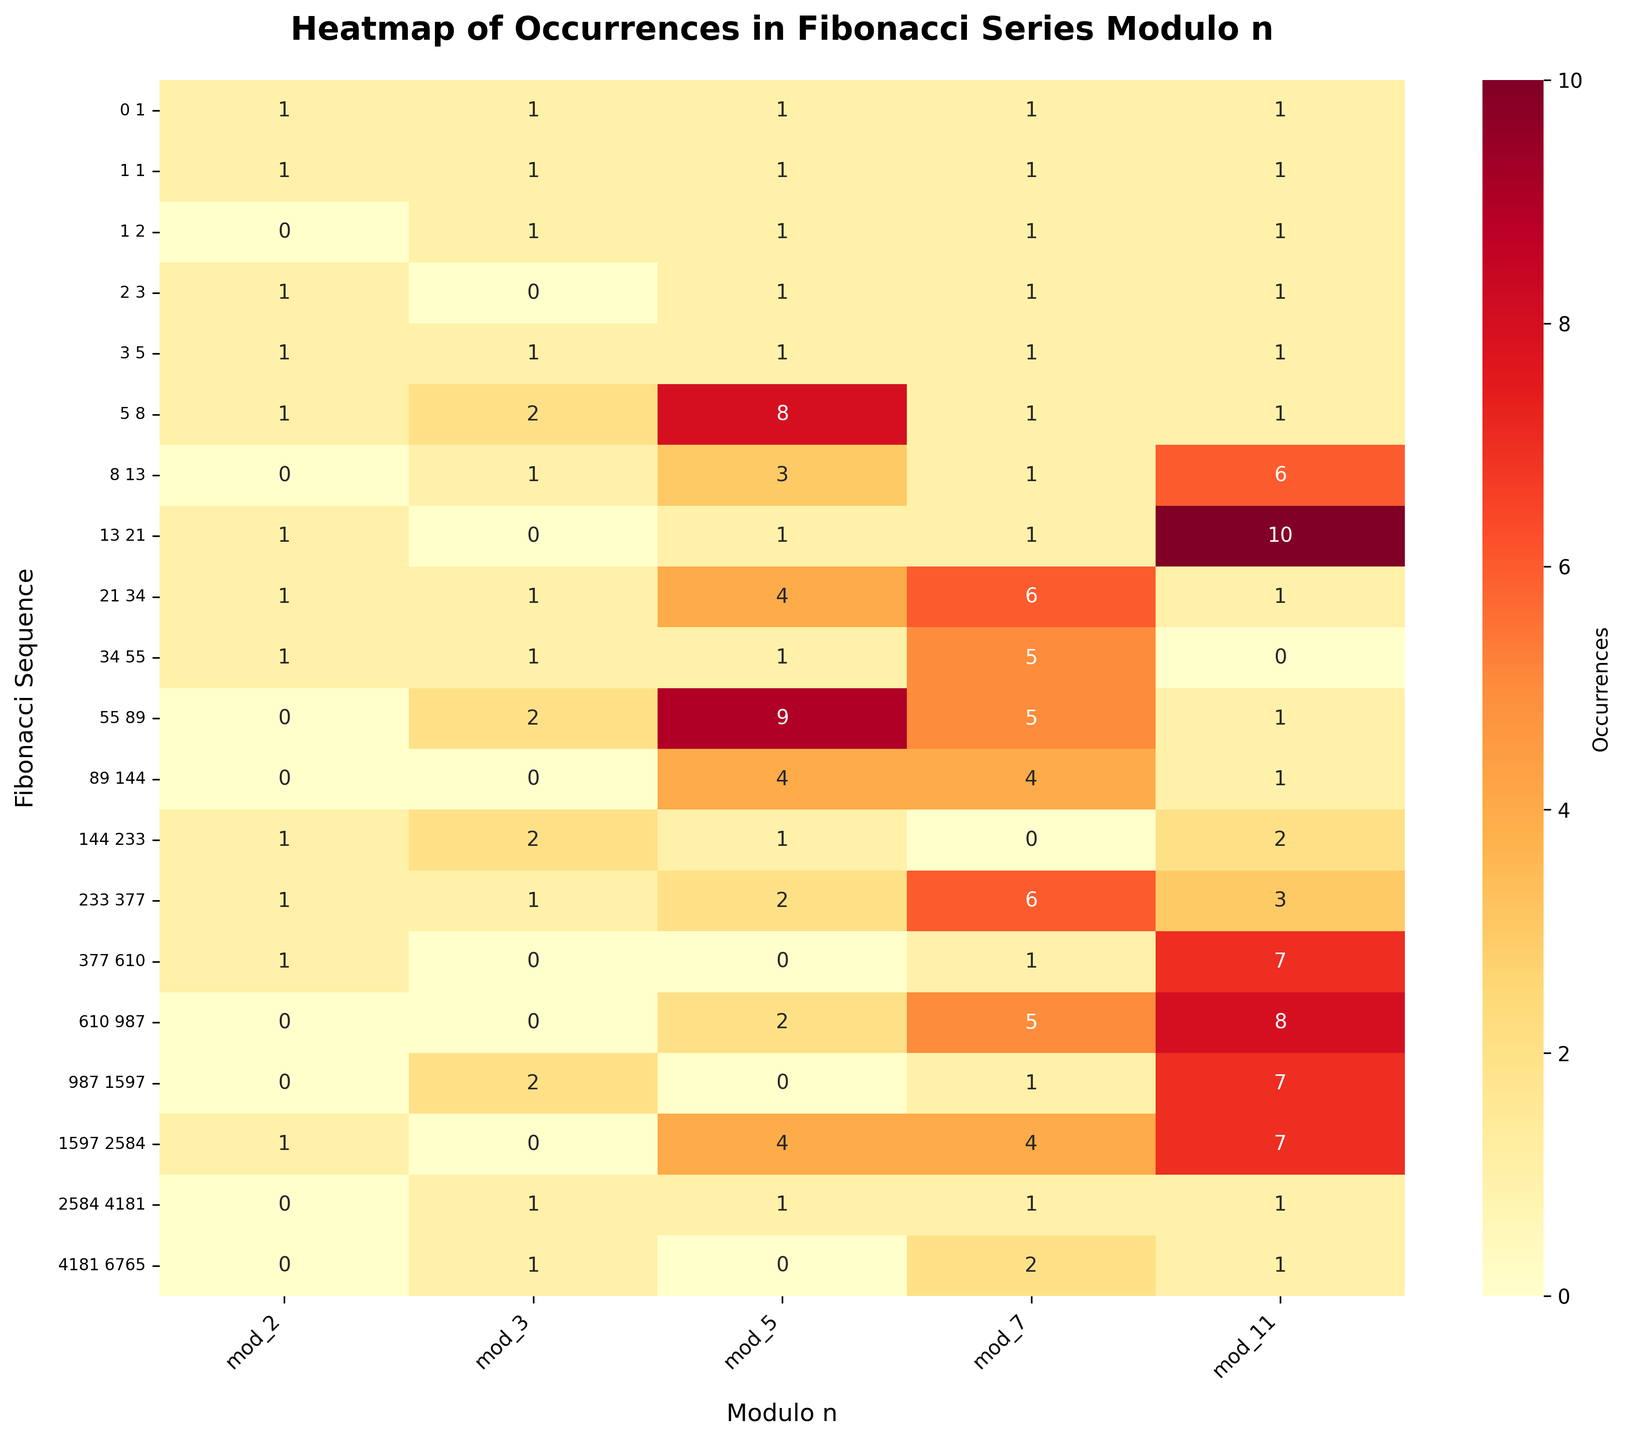What's the title of the heatmap? The title is typically found at the top of the figure. In this case, it reads, "Heatmap of Occurrences in Fibonacci Series Modulo n".
Answer: Heatmap of Occurrences in Fibonacci Series Modulo n How many different sequences are there in the heatmap? The y-axis of the heatmap shows the number of different sequences. Counting the y-ticks, we see there are 20 sequences from "0 1" to "4181 6765".
Answer: 20 Which modulo base has the highest value for the sequence "5 8"? Locate the row labeled "5 8" and investigate the values. The highest value is found in the 'mod_5' column with a value of 8.
Answer: mod_5 What is the value for the sequence "1597 2584" under mod_7? Find the row labeled "1597 2584" and the column labeled 'mod_7'. The intersection gives the value, which is 4.
Answer: 4 Which sequence has the least occurrence under mod_11? Inspect the 'mod_11' column for the smallest value. The smallest value is 0, and it appears at "34 55".
Answer: 34 55 For which sequence and modulo combination do you see the value 10? Search the heatmap for the occurrence of the value 10. It appears at the intersection of the sequence "13 21" and 'mod_11'.
Answer: 13 21, mod_11 How many sequences have an occurrence value of 0 under mod_2? Check the 'mod_2' column for values of 0. These appear at three sequences: "1 2", "8 13", "55 89", and "987 1597", "610 987", and "2584 4181". Count the occurrences, thus a total of 6 sequences.
Answer: 6 Which modulo base has the most consistent high values across all sequences? To find the most consistent high values, compare each column. 'mod_11' has the highest and most frequent values above others across many sequences.
Answer: mod_11 Which sequence and modulo combination show a value of 7? Find the value 7 in the heatmap, which appears at several intersections: "377 610" with 'mod_11' and "987 1597" with 'mod_11'.
Answer: 377 610, mod_11 and 987 1597, mod_11 